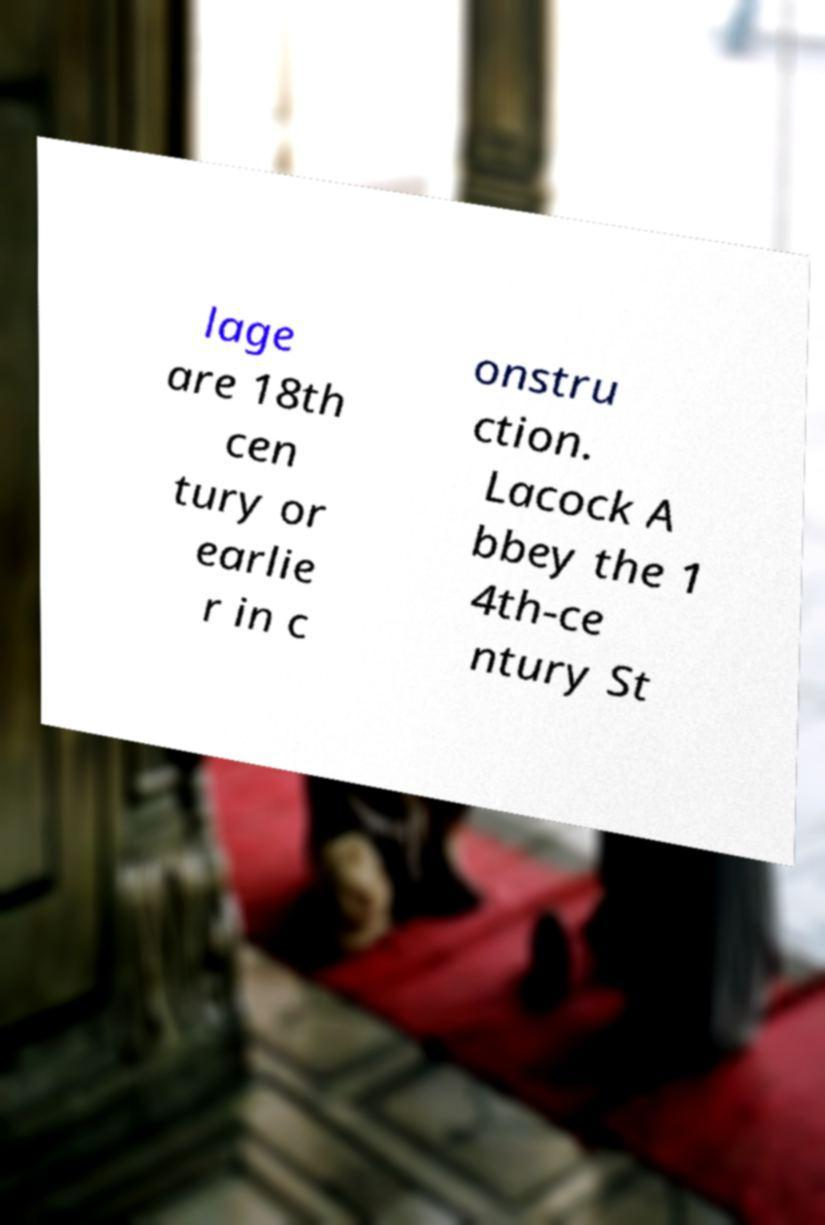Please identify and transcribe the text found in this image. lage are 18th cen tury or earlie r in c onstru ction. Lacock A bbey the 1 4th-ce ntury St 